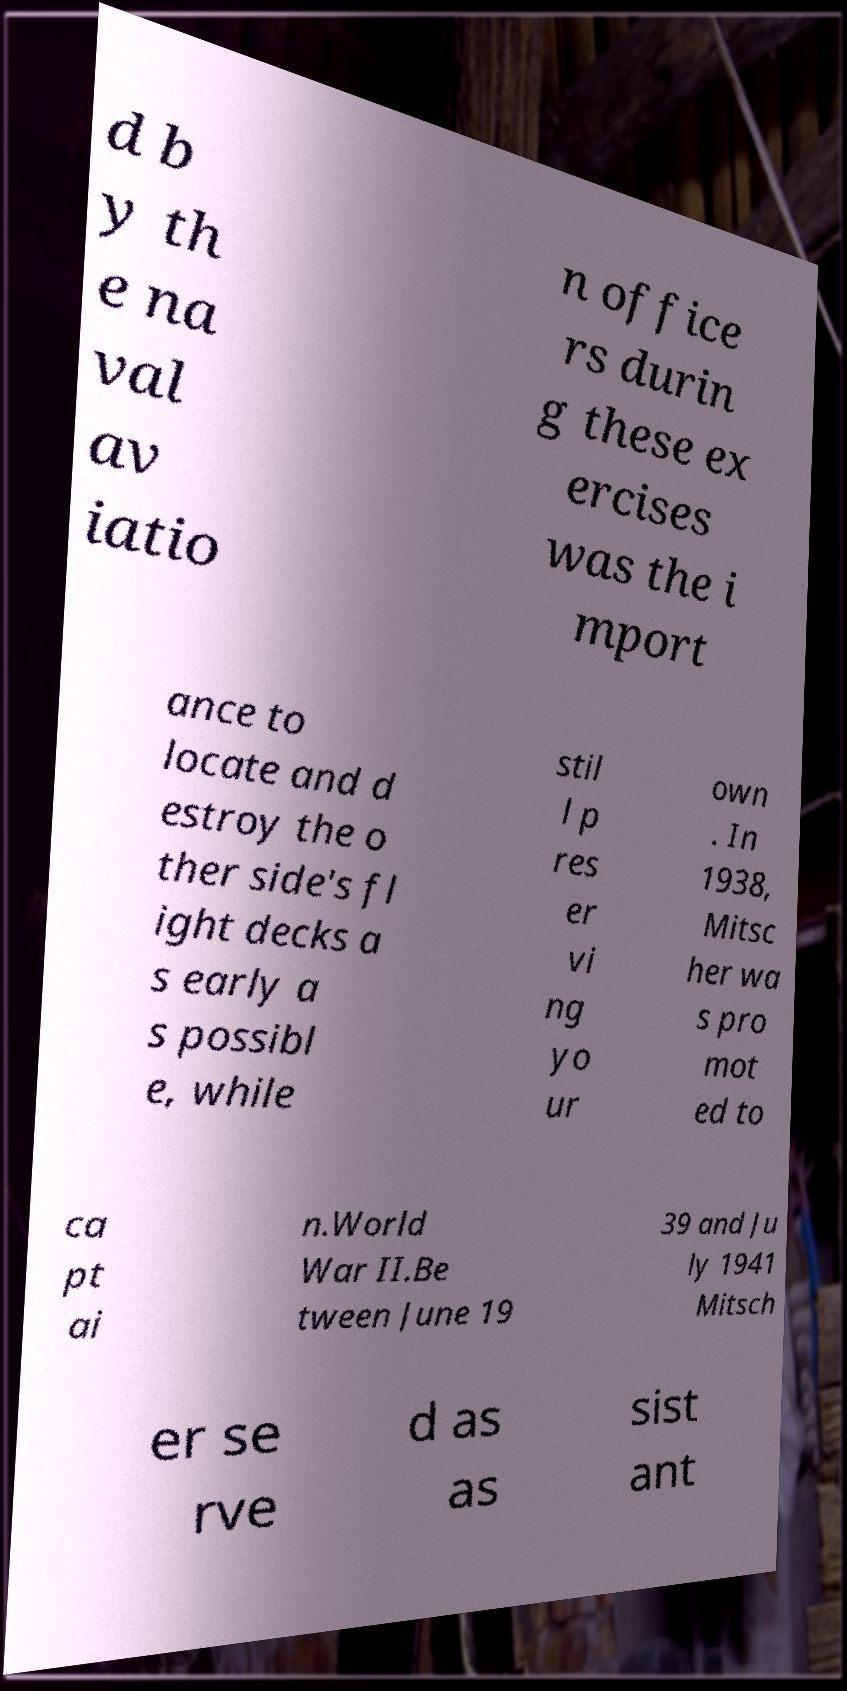Can you read and provide the text displayed in the image?This photo seems to have some interesting text. Can you extract and type it out for me? d b y th e na val av iatio n office rs durin g these ex ercises was the i mport ance to locate and d estroy the o ther side's fl ight decks a s early a s possibl e, while stil l p res er vi ng yo ur own . In 1938, Mitsc her wa s pro mot ed to ca pt ai n.World War II.Be tween June 19 39 and Ju ly 1941 Mitsch er se rve d as as sist ant 